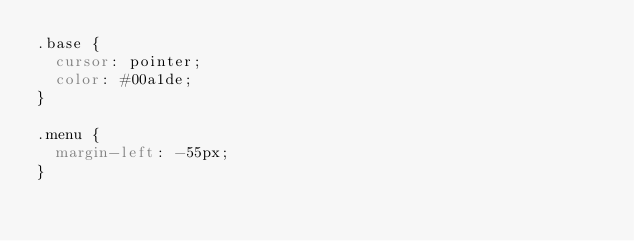<code> <loc_0><loc_0><loc_500><loc_500><_CSS_>.base {
  cursor: pointer;
  color: #00a1de;
}

.menu {
  margin-left: -55px;
}
</code> 